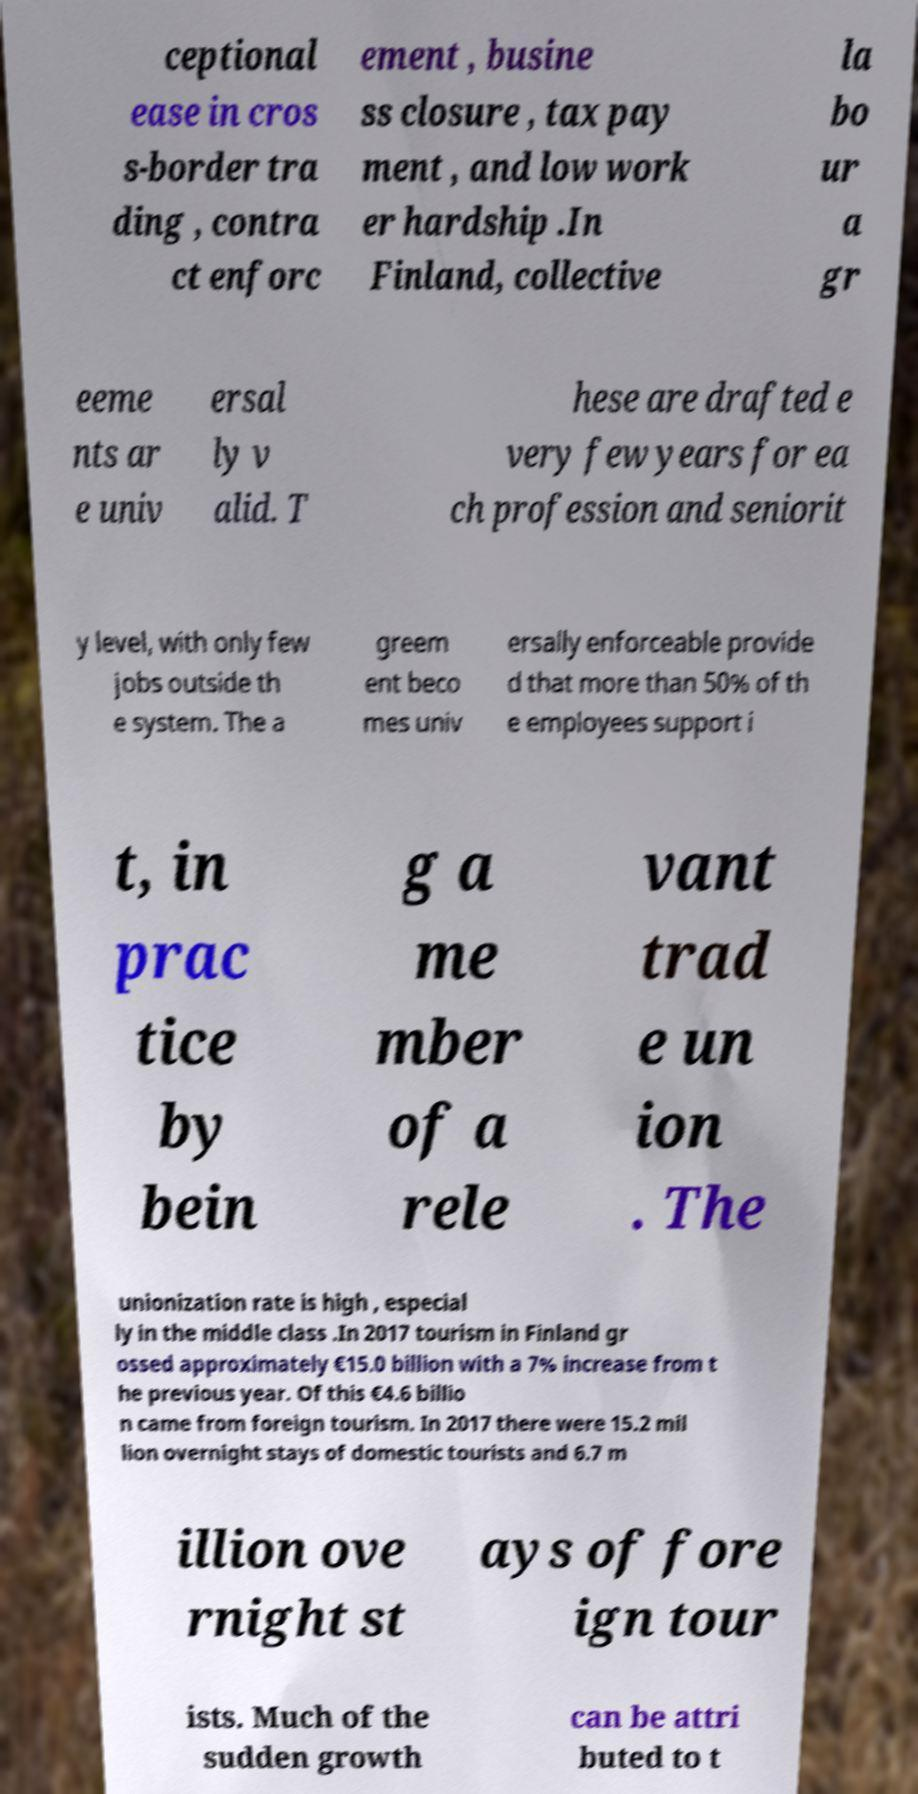Can you read and provide the text displayed in the image?This photo seems to have some interesting text. Can you extract and type it out for me? ceptional ease in cros s-border tra ding , contra ct enforc ement , busine ss closure , tax pay ment , and low work er hardship .In Finland, collective la bo ur a gr eeme nts ar e univ ersal ly v alid. T hese are drafted e very few years for ea ch profession and seniorit y level, with only few jobs outside th e system. The a greem ent beco mes univ ersally enforceable provide d that more than 50% of th e employees support i t, in prac tice by bein g a me mber of a rele vant trad e un ion . The unionization rate is high , especial ly in the middle class .In 2017 tourism in Finland gr ossed approximately €15.0 billion with a 7% increase from t he previous year. Of this €4.6 billio n came from foreign tourism. In 2017 there were 15.2 mil lion overnight stays of domestic tourists and 6.7 m illion ove rnight st ays of fore ign tour ists. Much of the sudden growth can be attri buted to t 